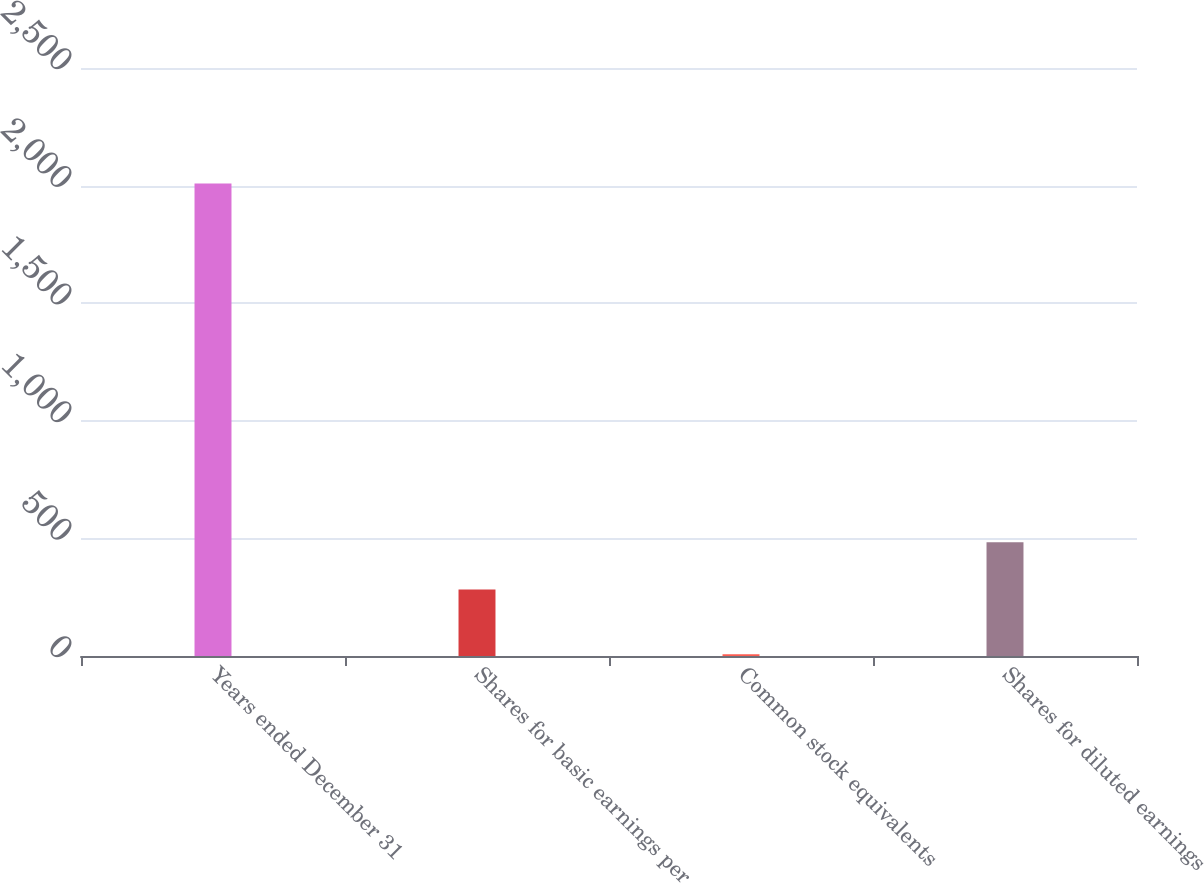<chart> <loc_0><loc_0><loc_500><loc_500><bar_chart><fcel>Years ended December 31<fcel>Shares for basic earnings per<fcel>Common stock equivalents<fcel>Shares for diluted earnings<nl><fcel>2009<fcel>283.2<fcel>7.9<fcel>483.31<nl></chart> 